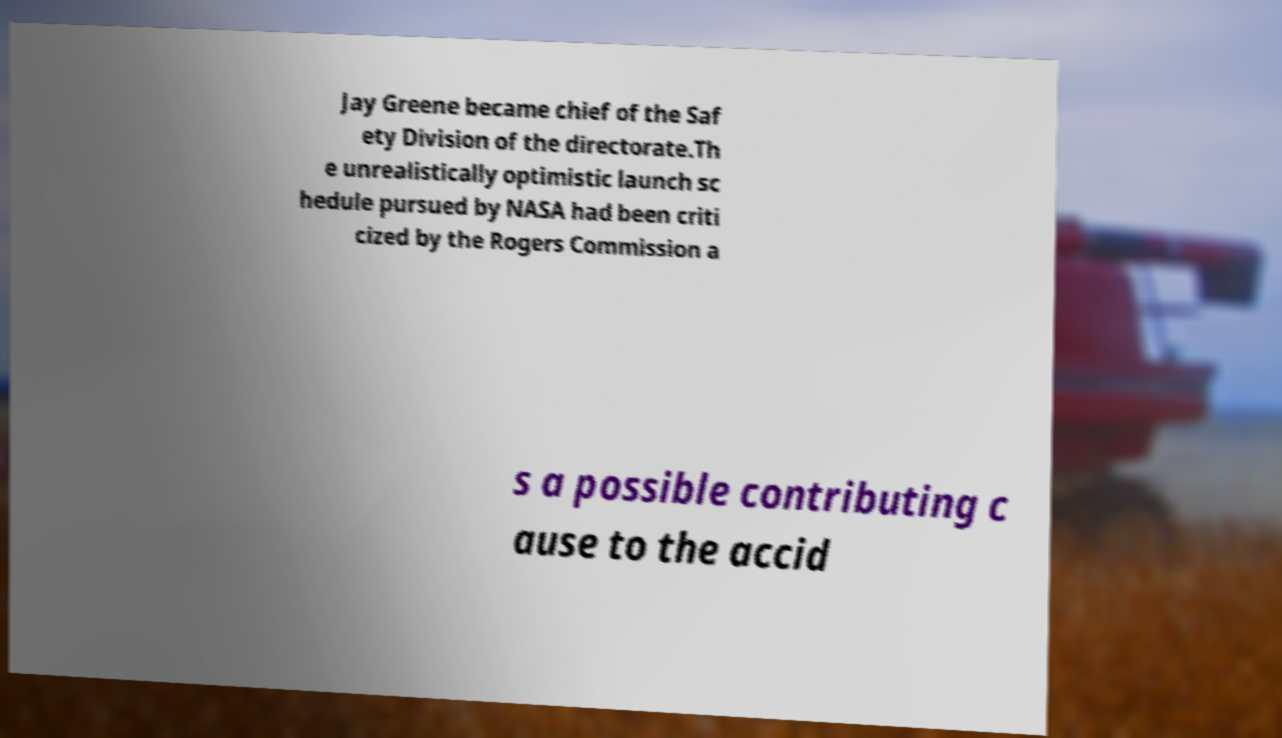Please identify and transcribe the text found in this image. Jay Greene became chief of the Saf ety Division of the directorate.Th e unrealistically optimistic launch sc hedule pursued by NASA had been criti cized by the Rogers Commission a s a possible contributing c ause to the accid 